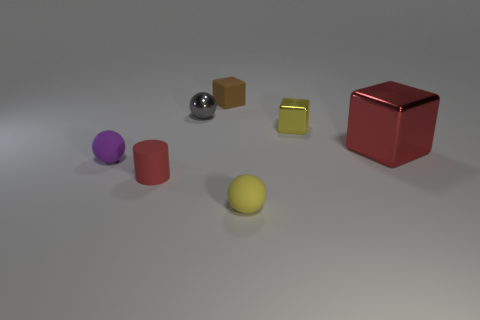What number of tiny purple matte balls are there?
Your answer should be very brief. 1. The small matte thing behind the small shiny object to the right of the sphere behind the large metallic object is what color?
Your response must be concise. Brown. Are there fewer blue matte objects than tiny yellow matte things?
Offer a very short reply. Yes. The other matte thing that is the same shape as the small purple rubber object is what color?
Offer a terse response. Yellow. What color is the tiny block that is made of the same material as the tiny red cylinder?
Offer a terse response. Brown. What number of red matte cylinders have the same size as the red metallic block?
Ensure brevity in your answer.  0. What is the material of the small red cylinder?
Your answer should be compact. Rubber. Are there more small cyan spheres than objects?
Your response must be concise. No. Do the tiny purple object and the yellow matte object have the same shape?
Your answer should be very brief. Yes. Is there anything else that is the same shape as the small gray thing?
Provide a short and direct response. Yes. 